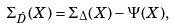<formula> <loc_0><loc_0><loc_500><loc_500>\Sigma _ { \hat { D } } ( X ) = \Sigma _ { \Delta } ( X ) - \Psi ( X ) ,</formula> 